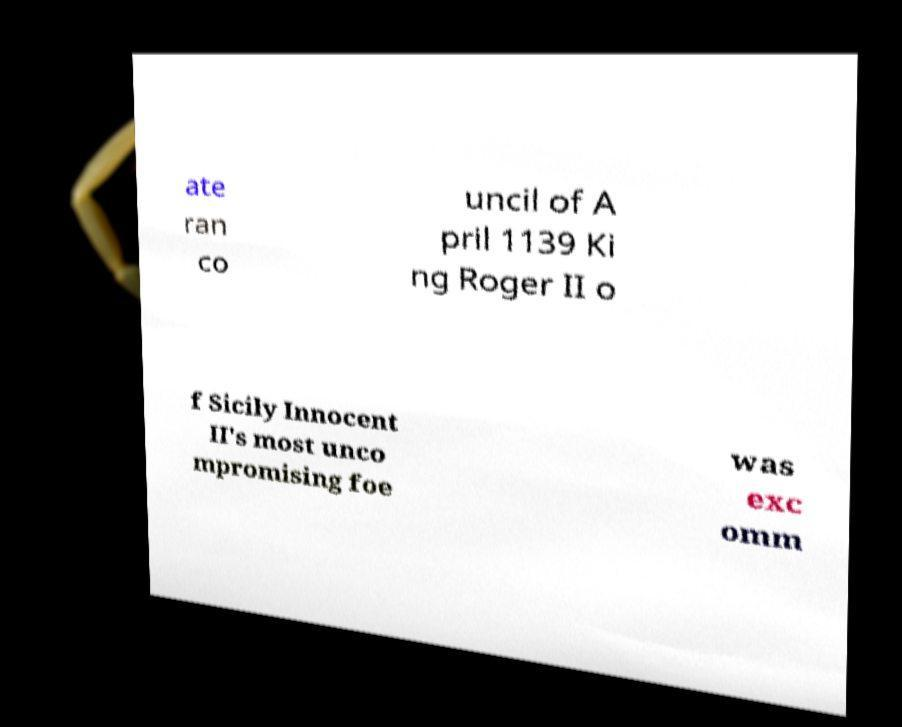Please identify and transcribe the text found in this image. ate ran co uncil of A pril 1139 Ki ng Roger II o f Sicily Innocent II's most unco mpromising foe was exc omm 